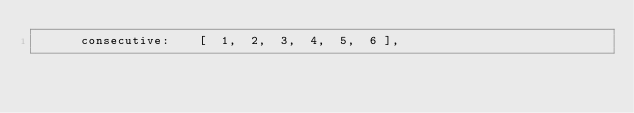<code> <loc_0><loc_0><loc_500><loc_500><_TypeScript_>      consecutive:    [  1,  2,  3,  4,  5,  6 ],</code> 